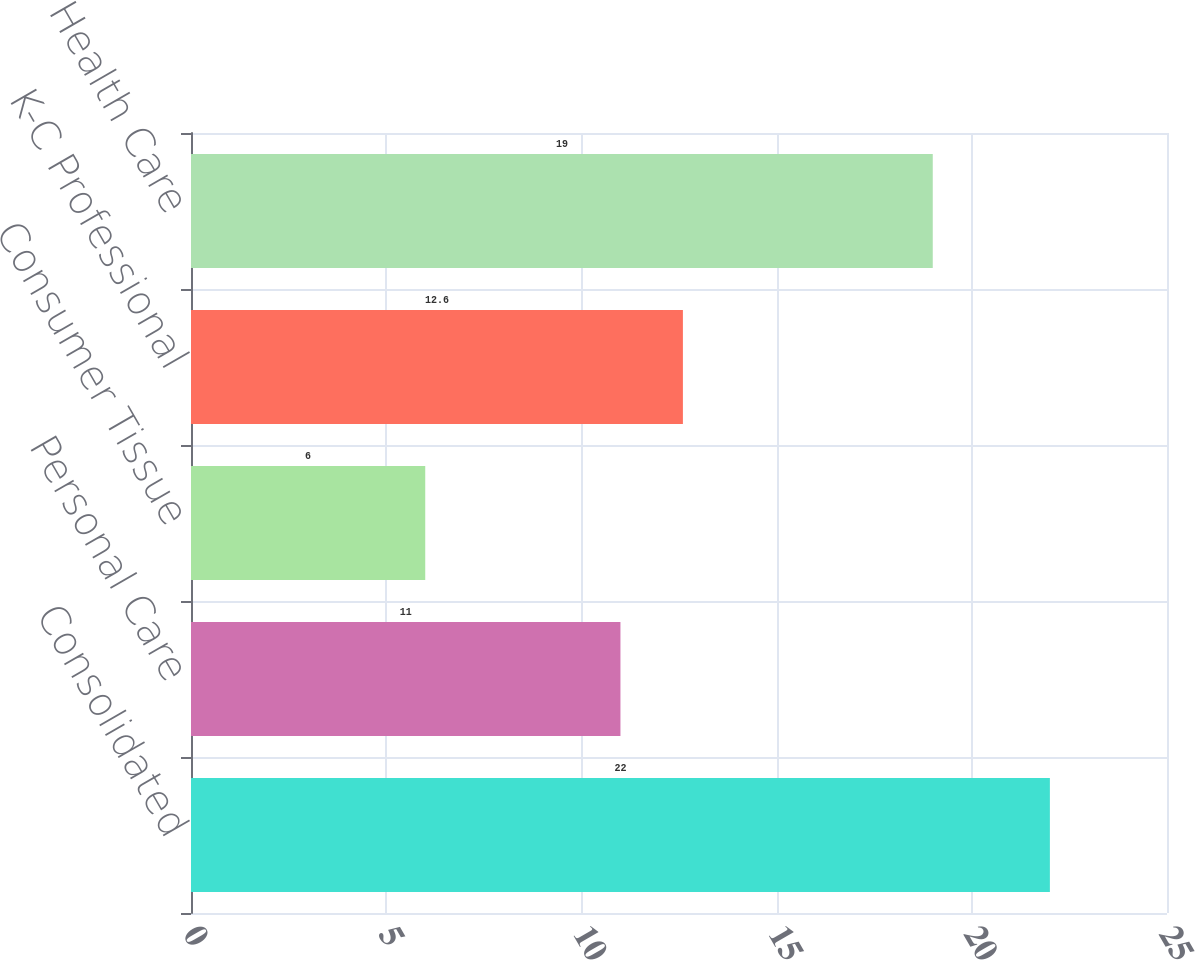<chart> <loc_0><loc_0><loc_500><loc_500><bar_chart><fcel>Consolidated<fcel>Personal Care<fcel>Consumer Tissue<fcel>K-C Professional<fcel>Health Care<nl><fcel>22<fcel>11<fcel>6<fcel>12.6<fcel>19<nl></chart> 